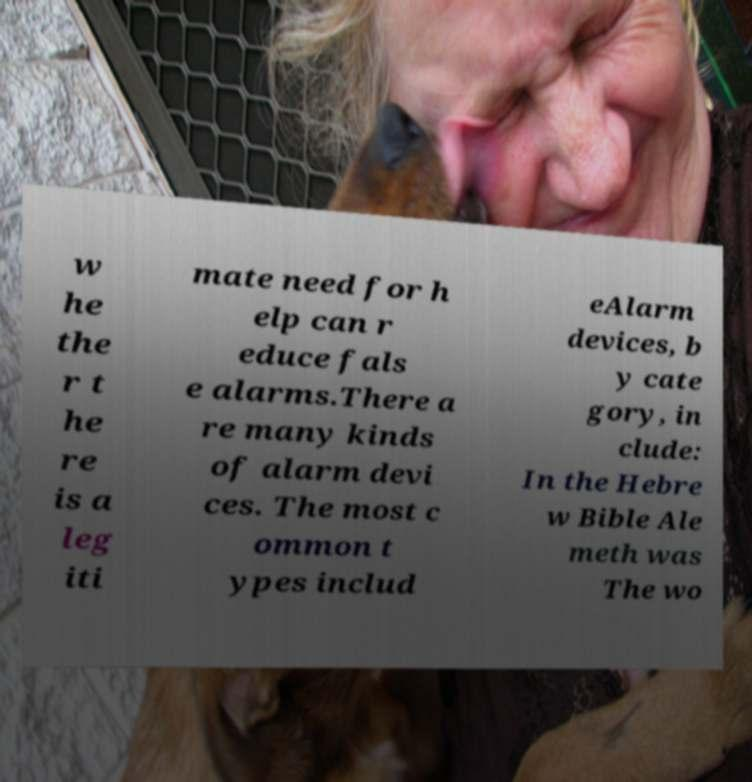Please read and relay the text visible in this image. What does it say? w he the r t he re is a leg iti mate need for h elp can r educe fals e alarms.There a re many kinds of alarm devi ces. The most c ommon t ypes includ eAlarm devices, b y cate gory, in clude: In the Hebre w Bible Ale meth was The wo 